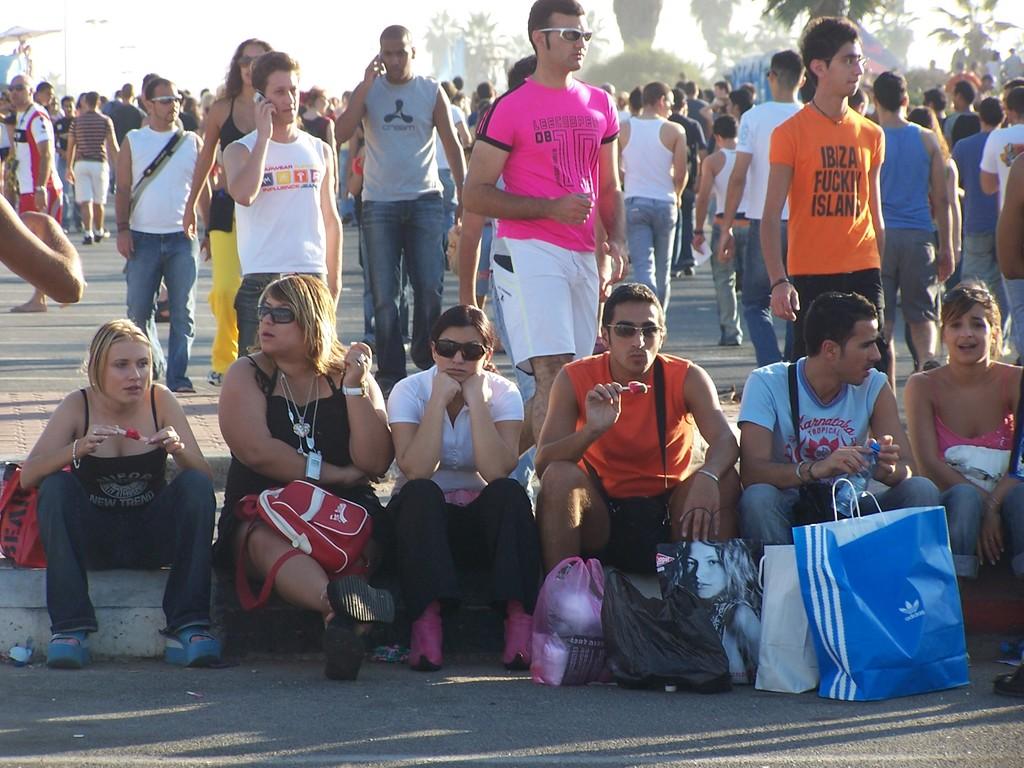Is there someone with a pink shirt in the photo?
Offer a very short reply. Yes. What kind of island is the person in the orange shirt talking about?
Offer a very short reply. Ibiza. 